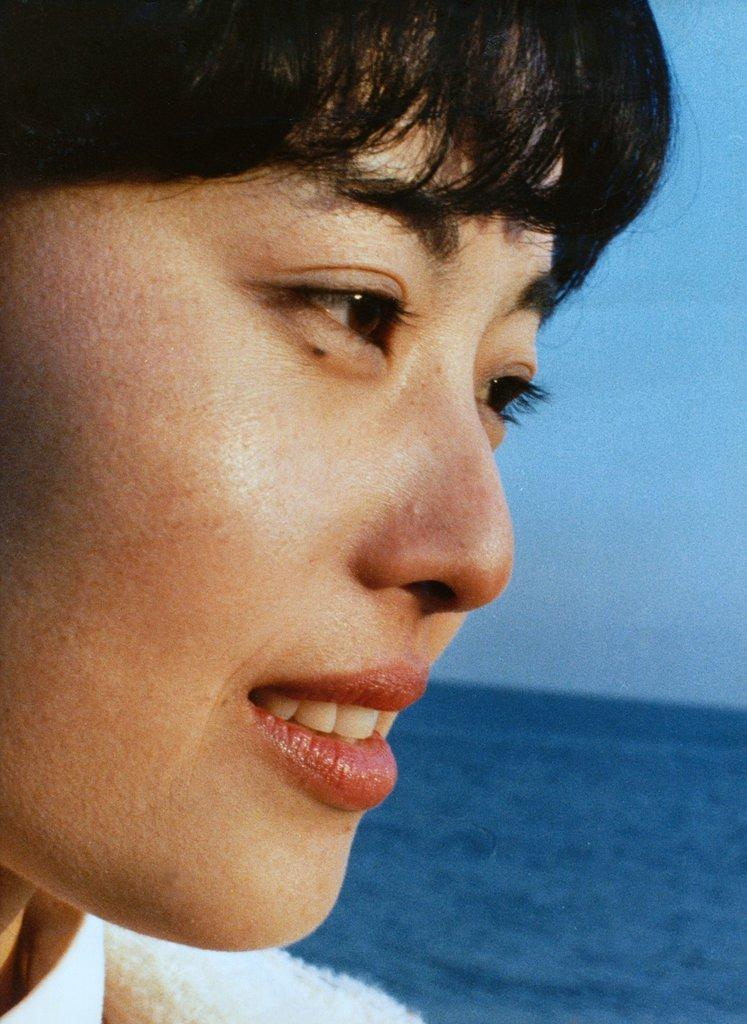What is present in the image? There is a woman in the image. In which direction is the woman looking? The woman is looking to the right side. What can be seen in the background of the image? There is water and the sky visible in the background of the image. What type of club is the woman holding in the image? There is no club present in the image; the woman is simply looking to the right side. What angle is the woman positioned at in the image? The angle at which the woman is positioned cannot be determined from the image alone. 